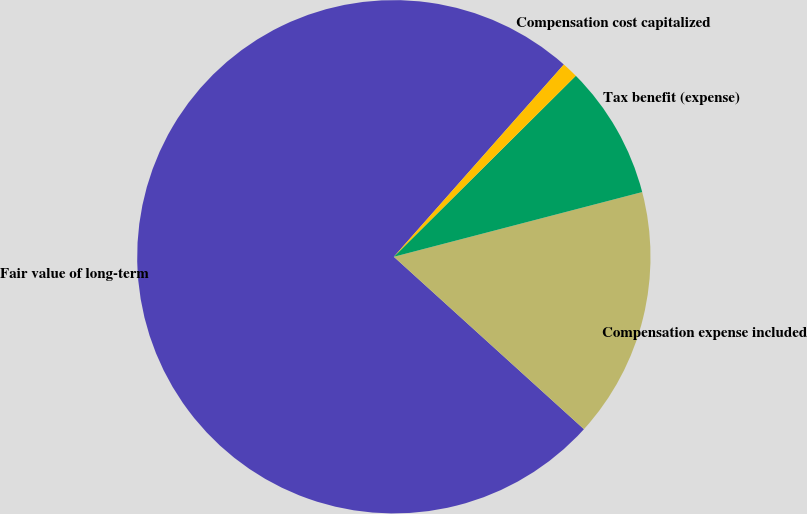Convert chart to OTSL. <chart><loc_0><loc_0><loc_500><loc_500><pie_chart><fcel>Fair value of long-term<fcel>Compensation expense included<fcel>Tax benefit (expense)<fcel>Compensation cost capitalized<nl><fcel>74.8%<fcel>15.78%<fcel>8.4%<fcel>1.02%<nl></chart> 